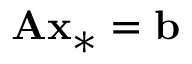Convert formula to latex. <formula><loc_0><loc_0><loc_500><loc_500>A x _ { * } = b</formula> 